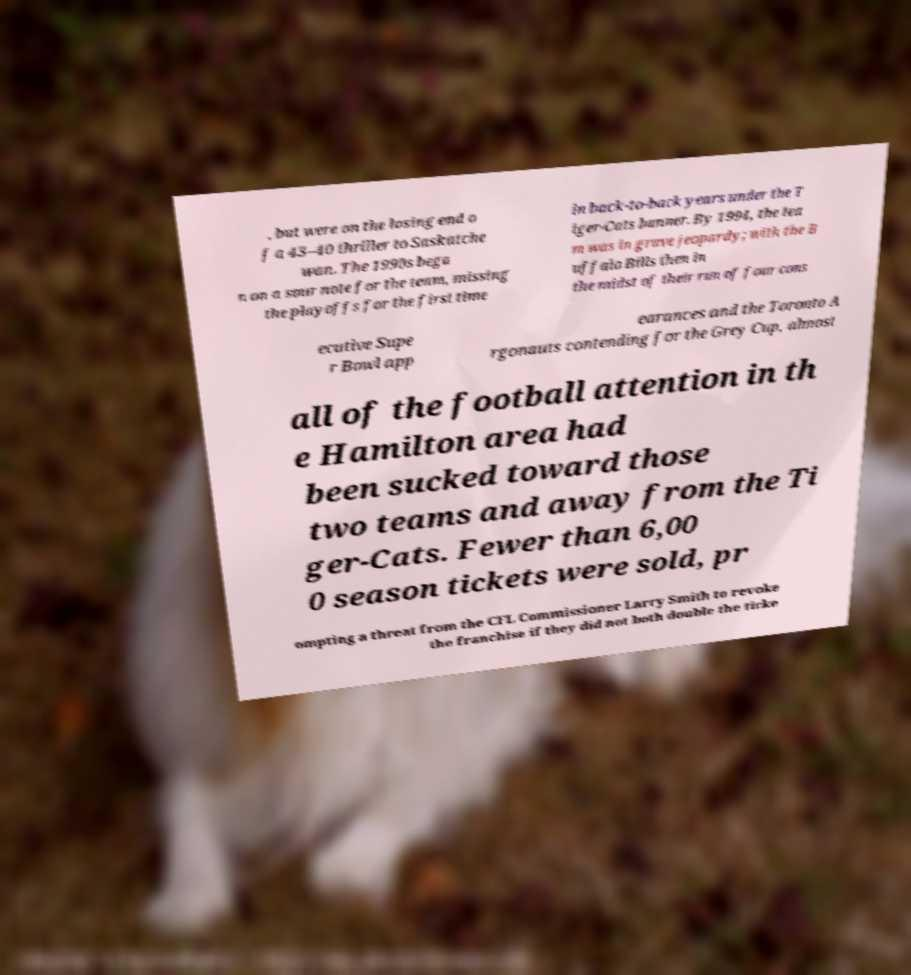What messages or text are displayed in this image? I need them in a readable, typed format. , but were on the losing end o f a 43–40 thriller to Saskatche wan. The 1990s bega n on a sour note for the team, missing the playoffs for the first time in back-to-back years under the T iger-Cats banner. By 1994, the tea m was in grave jeopardy; with the B uffalo Bills then in the midst of their run of four cons ecutive Supe r Bowl app earances and the Toronto A rgonauts contending for the Grey Cup, almost all of the football attention in th e Hamilton area had been sucked toward those two teams and away from the Ti ger-Cats. Fewer than 6,00 0 season tickets were sold, pr ompting a threat from the CFL Commissioner Larry Smith to revoke the franchise if they did not both double the ticke 